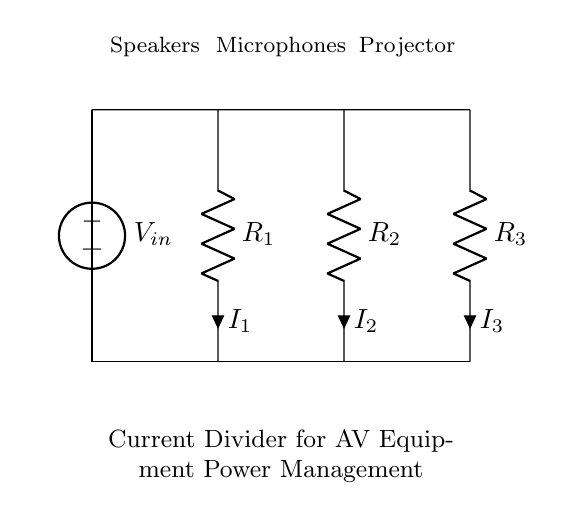What are the components in this circuit? The components include a voltage source, three resistors, and connections indicated by lines. The voltage source is labeled as V_in and the resistors as R_1, R_2, and R_3.
Answer: Voltage source, three resistors What is the function of the resistors in this circuit? The resistors R_1, R_2, and R_3 are used to divide the input current from the voltage source based on their resistances, creating different currents for each path.
Answer: Current division What are the currents in the circuit? The currents are labeled as I_1, I_2, and I_3, corresponding to their respective resistors. The exact values depend on the resistances and input voltage.
Answer: I_1, I_2, I_3 How is current distributed among the resistors? Current is divided among the resistors in inverse proportion to their resistances. This means that a lower resistor value gets more current while a higher one receives less.
Answer: Inverse proportion to resistance What is the configuration type of this circuit? This circuit is a current divider configuration as it splits total input current into multiple paths through different resistors that connect in parallel.
Answer: Current divider What can be inferred about the input voltage in the circuit? The input voltage, labeled V_in, is applied to the circuit and serves as the source of the current. The voltage across each resistor will remain the same as V_in due to their parallel arrangement.
Answer: Same as V_in Which components are connected to the microphones in the circuit? The component connected to the microphones is resistor R_2, which is responsible for carrying the current designated as I_2 to that part of the equipment.
Answer: Resistor R_2 